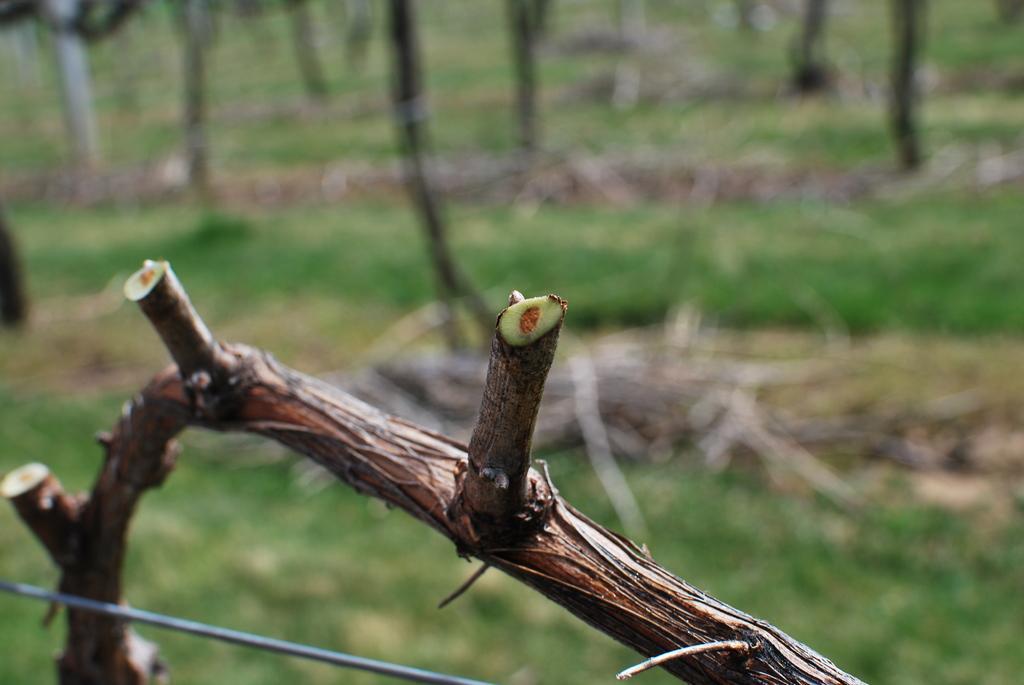How would you summarize this image in a sentence or two? In this image there is a wooden object towards the bottom of the image that looks like a branch of a tree, there is a wire towards the bottom of the image, there is grass towards the bottom of the image, there are objects on the ground, there are objects towards the top of the image that looks like tree trunks. 